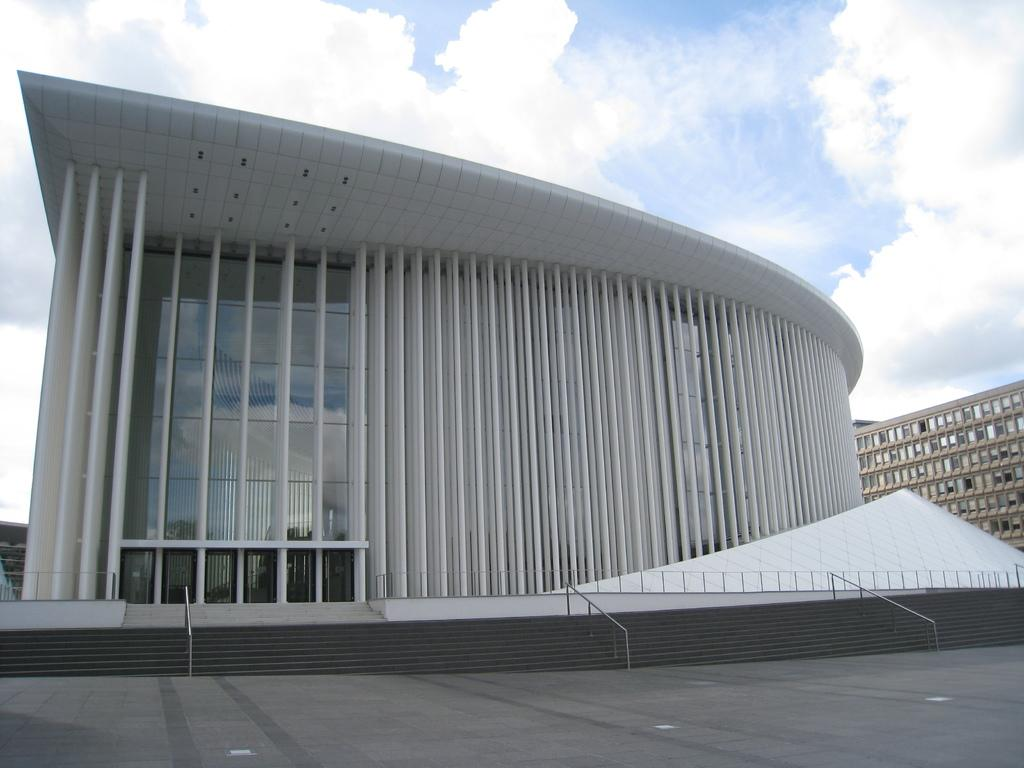What type of structures can be seen in the image? There are buildings in the image. What part of the image is visible beneath the buildings? The floor is visible in the image. Are there any architectural features that allow for movement between different levels? Yes, there are steps in the image. Is there any safety feature associated with the steps? Yes, there is a railing in the image. What can be seen in the background of the image? The sky is visible in the background of the image, and there are clouds in the sky. Can you see a kite flying in the sky in the image? There is no kite visible in the sky in the image. Is there an arch visible in the image? There is no arch present in the image. 